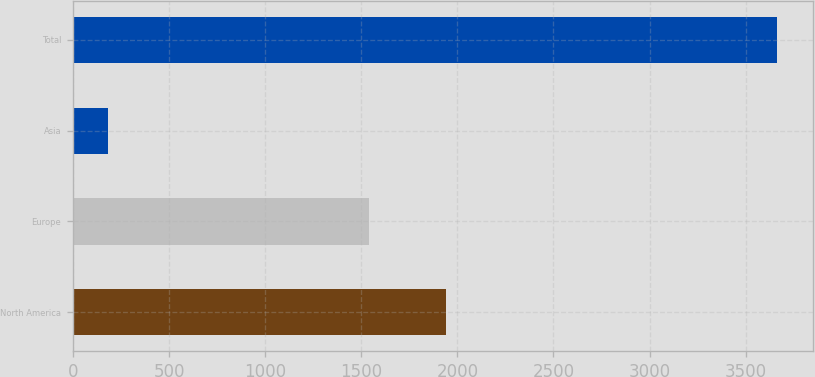Convert chart to OTSL. <chart><loc_0><loc_0><loc_500><loc_500><bar_chart><fcel>North America<fcel>Europe<fcel>Asia<fcel>Total<nl><fcel>1942<fcel>1541<fcel>182<fcel>3665<nl></chart> 